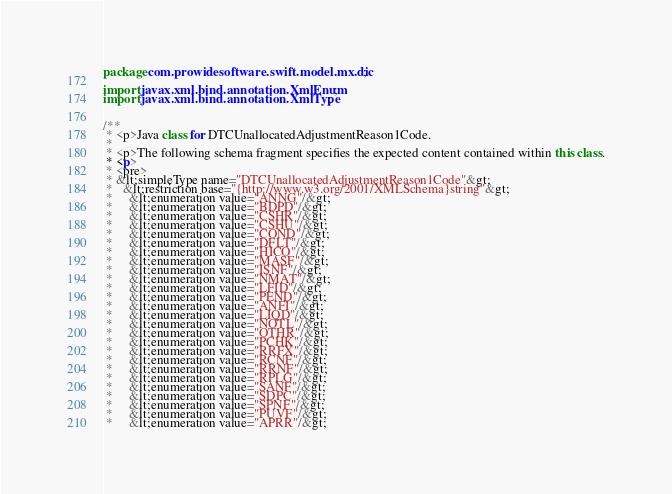Convert code to text. <code><loc_0><loc_0><loc_500><loc_500><_Java_>
package com.prowidesoftware.swift.model.mx.dic;

import javax.xml.bind.annotation.XmlEnum;
import javax.xml.bind.annotation.XmlType;


/**
 * <p>Java class for DTCUnallocatedAdjustmentReason1Code.
 * 
 * <p>The following schema fragment specifies the expected content contained within this class.
 * <p>
 * <pre>
 * &lt;simpleType name="DTCUnallocatedAdjustmentReason1Code"&gt;
 *   &lt;restriction base="{http://www.w3.org/2001/XMLSchema}string"&gt;
 *     &lt;enumeration value="ANNG"/&gt;
 *     &lt;enumeration value="BDPD"/&gt;
 *     &lt;enumeration value="CSHR"/&gt;
 *     &lt;enumeration value="CSHU"/&gt;
 *     &lt;enumeration value="COND"/&gt;
 *     &lt;enumeration value="DFLT"/&gt;
 *     &lt;enumeration value="HICO"/&gt;
 *     &lt;enumeration value="MASF"/&gt;
 *     &lt;enumeration value="ISNF"/&gt;
 *     &lt;enumeration value="NMAT"/&gt;
 *     &lt;enumeration value="LFID"/&gt;
 *     &lt;enumeration value="PEND"/&gt;
 *     &lt;enumeration value="ANFI"/&gt;
 *     &lt;enumeration value="LIQD"/&gt;
 *     &lt;enumeration value="NOTL"/&gt;
 *     &lt;enumeration value="OTHR"/&gt;
 *     &lt;enumeration value="PCHK"/&gt;
 *     &lt;enumeration value="RRFX"/&gt;
 *     &lt;enumeration value="RCNF"/&gt;
 *     &lt;enumeration value="RRNF"/&gt;
 *     &lt;enumeration value="RPLG"/&gt;
 *     &lt;enumeration value="SANF"/&gt;
 *     &lt;enumeration value="SDPC"/&gt;
 *     &lt;enumeration value="SPNF"/&gt;
 *     &lt;enumeration value="PUVF"/&gt;
 *     &lt;enumeration value="APRR"/&gt;</code> 